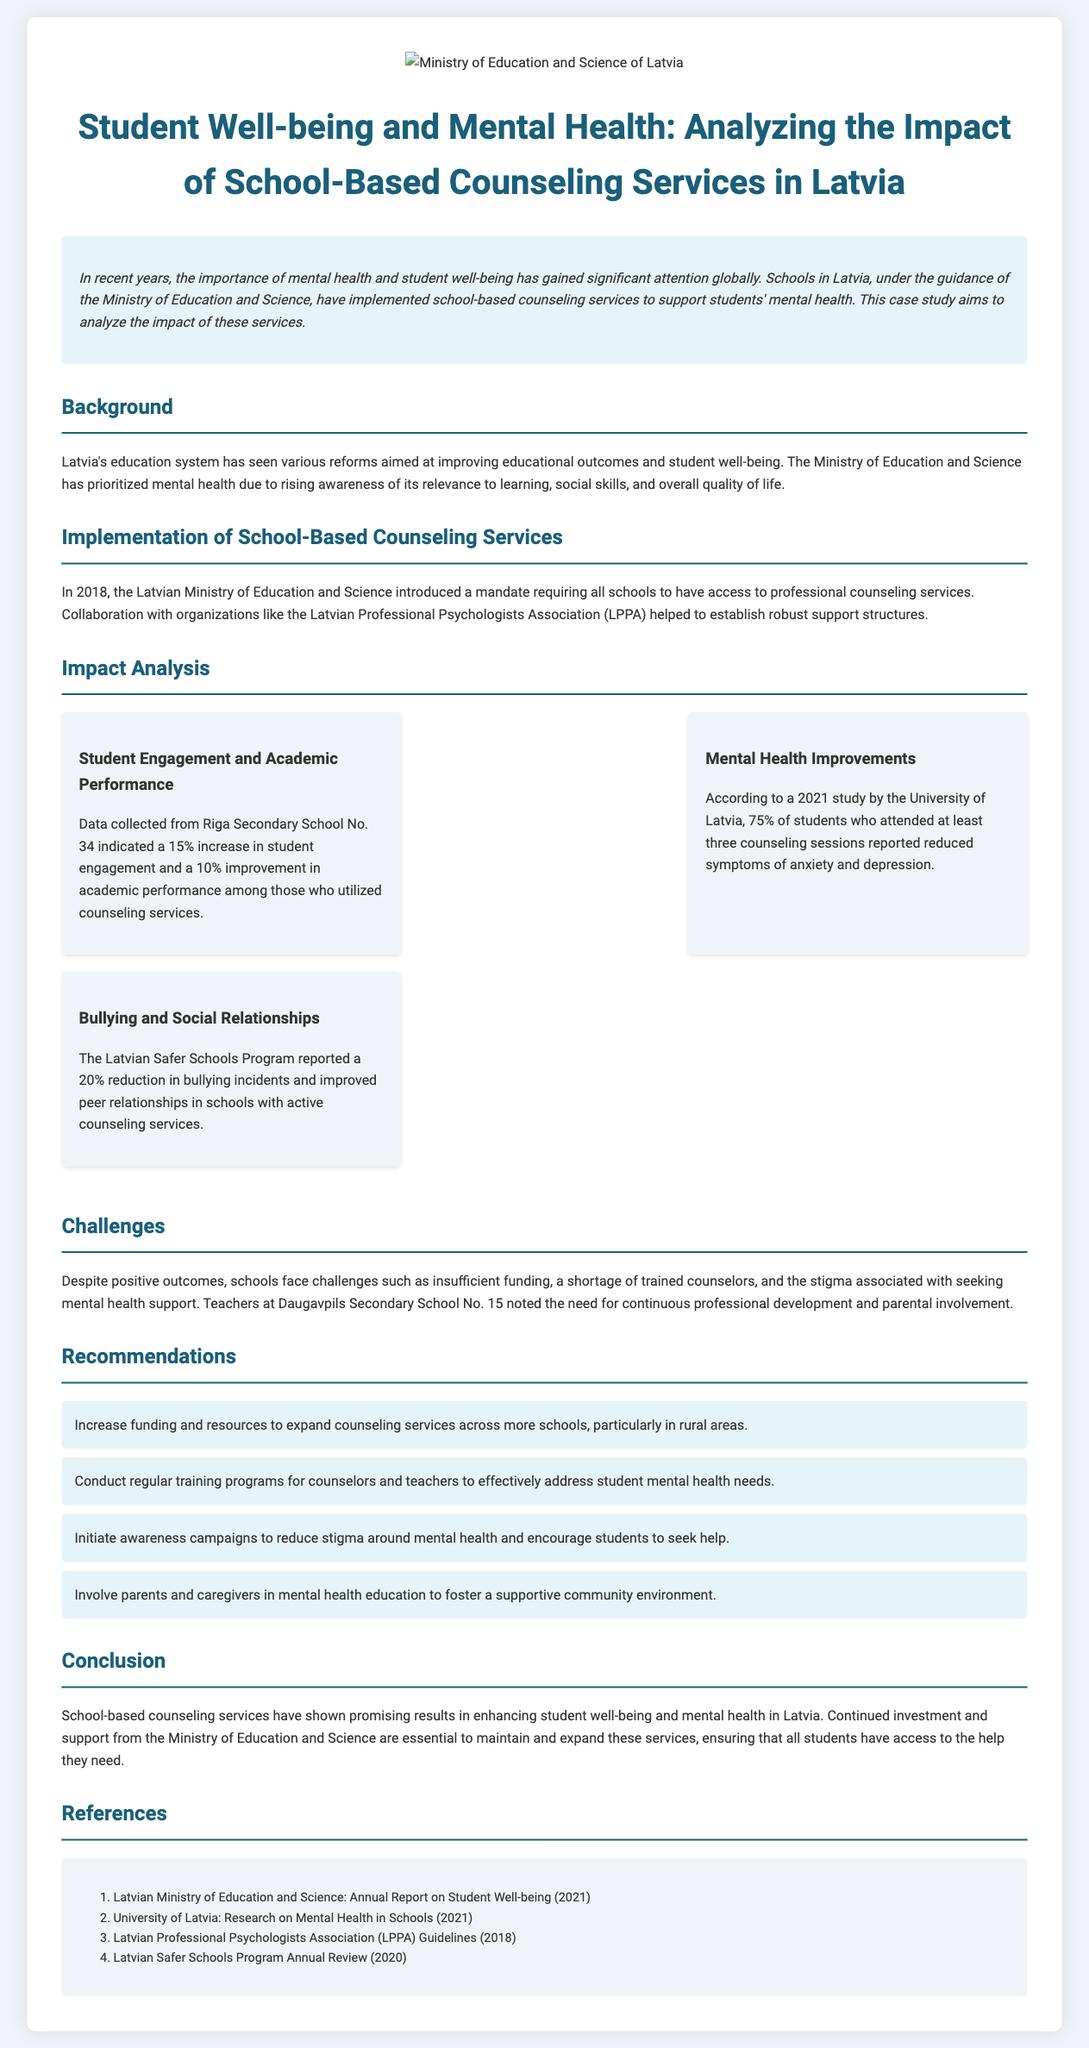What is the title of the case study? The title is stated at the beginning of the document.
Answer: Student Well-being and Mental Health: Analyzing the Impact of School-Based Counseling Services in Latvia In what year did Latvia introduce the mandate for school-based counseling services? The document specifies the year when this mandate was established.
Answer: 2018 What percentage of students reported reduced symptoms of anxiety and depression after counseling? This information is found in the impact analysis section regarding mental health improvements.
Answer: 75% Which school reported a 15% increase in student engagement? The impact analysis lists specific schools that provided data on engagement levels.
Answer: Riga Secondary School No. 34 What is one of the challenges faced by schools in implementing counseling services? The challenges section mentions several issues schools encounter with counseling services.
Answer: Insufficient funding List one recommendation made in the case study. The recommendations section outlines several proposed actions to improve counseling services.
Answer: Increase funding and resources What program reported a 20% reduction in bullying incidents? The document highlights specific programs in relation to the impact of counseling services.
Answer: Latvian Safer Schools Program What does the case study suggest about parental involvement? The recommendations discuss the role of parents in supporting mental health education.
Answer: Foster a supportive community environment 